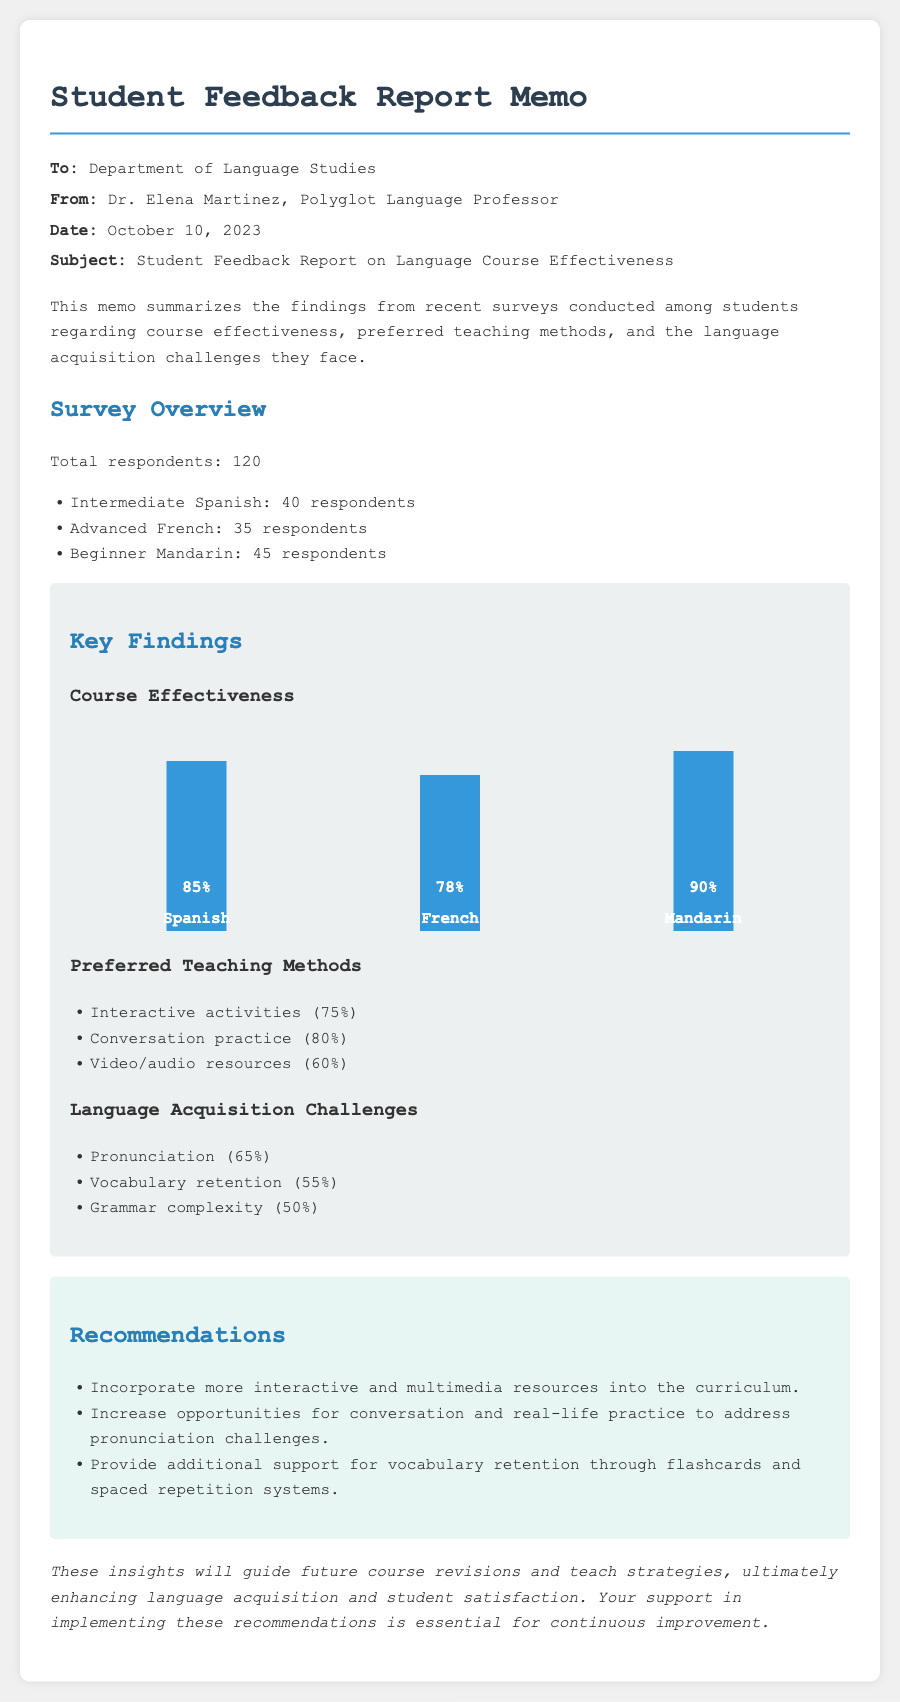what is the total number of respondents? The total number of respondents is included in the survey overview section which states "Total respondents: 120."
Answer: 120 who is the author of the memo? The author's name is presented in the header of the memo: "Dr. Elena Martinez, Polyglot Language Professor."
Answer: Dr. Elena Martinez what percentage of students preferred interactive activities? The preferred teaching methods section lists the percentage for interactive activities as 75%.
Answer: 75% which language had the highest course effectiveness rating? The course effectiveness ratings show that Mandarin had the highest rating at 90%.
Answer: Mandarin what are the top two language acquisition challenges faced by students? The top two challenges listed are "Pronunciation (65%)" and "Vocabulary retention (55%)."
Answer: Pronunciation and Vocabulary retention how many respondents were there for Advanced French? The survey overview specifies that there were 35 respondents for Advanced French.
Answer: 35 what is one of the recommendations provided in the memo? The recommendations section states several suggestions, one being to "Incorporate more interactive and multimedia resources into the curriculum."
Answer: Incorporate more interactive and multimedia resources into the curriculum what percentage of students preferred conversation practice as a teaching method? The section on preferred teaching methods indicates that 80% of students preferred conversation practice.
Answer: 80% 